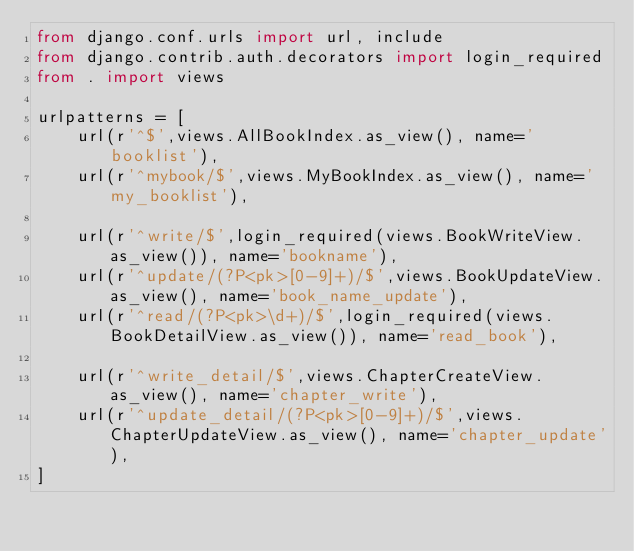Convert code to text. <code><loc_0><loc_0><loc_500><loc_500><_Python_>from django.conf.urls import url, include
from django.contrib.auth.decorators import login_required
from . import views

urlpatterns = [
    url(r'^$',views.AllBookIndex.as_view(), name='booklist'),
    url(r'^mybook/$',views.MyBookIndex.as_view(), name='my_booklist'),

    url(r'^write/$',login_required(views.BookWriteView.as_view()), name='bookname'),
    url(r'^update/(?P<pk>[0-9]+)/$',views.BookUpdateView.as_view(), name='book_name_update'),
    url(r'^read/(?P<pk>\d+)/$',login_required(views.BookDetailView.as_view()), name='read_book'),

   	url(r'^write_detail/$',views.ChapterCreateView.as_view(), name='chapter_write'),
   	url(r'^update_detail/(?P<pk>[0-9]+)/$',views.ChapterUpdateView.as_view(), name='chapter_update'),
]
</code> 